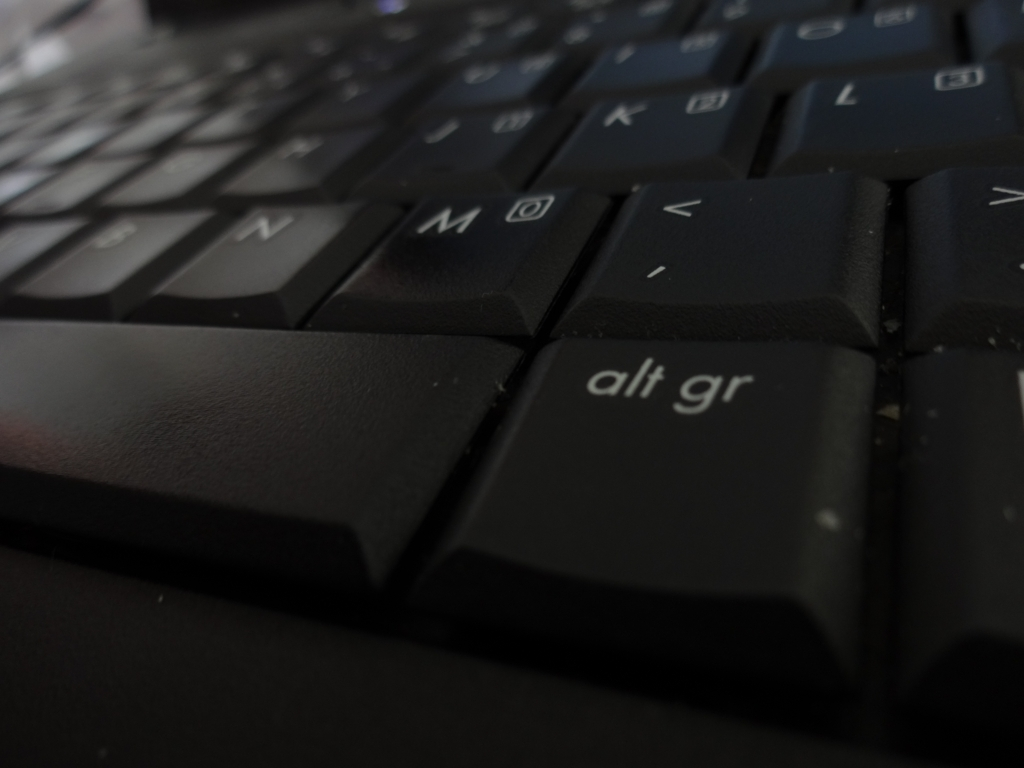Can you tell what kind of keyboard this is? Are there any distinguishing features? The keyboard in the image appears to be a standard, full-sized QWERTY keyboard. It has a prominent 'Alt Gr' key typically found on European layouts. The dark color scheme and the shape of the keys suggest it might be used for regular typing tasks, possibly in an office or home environment. 